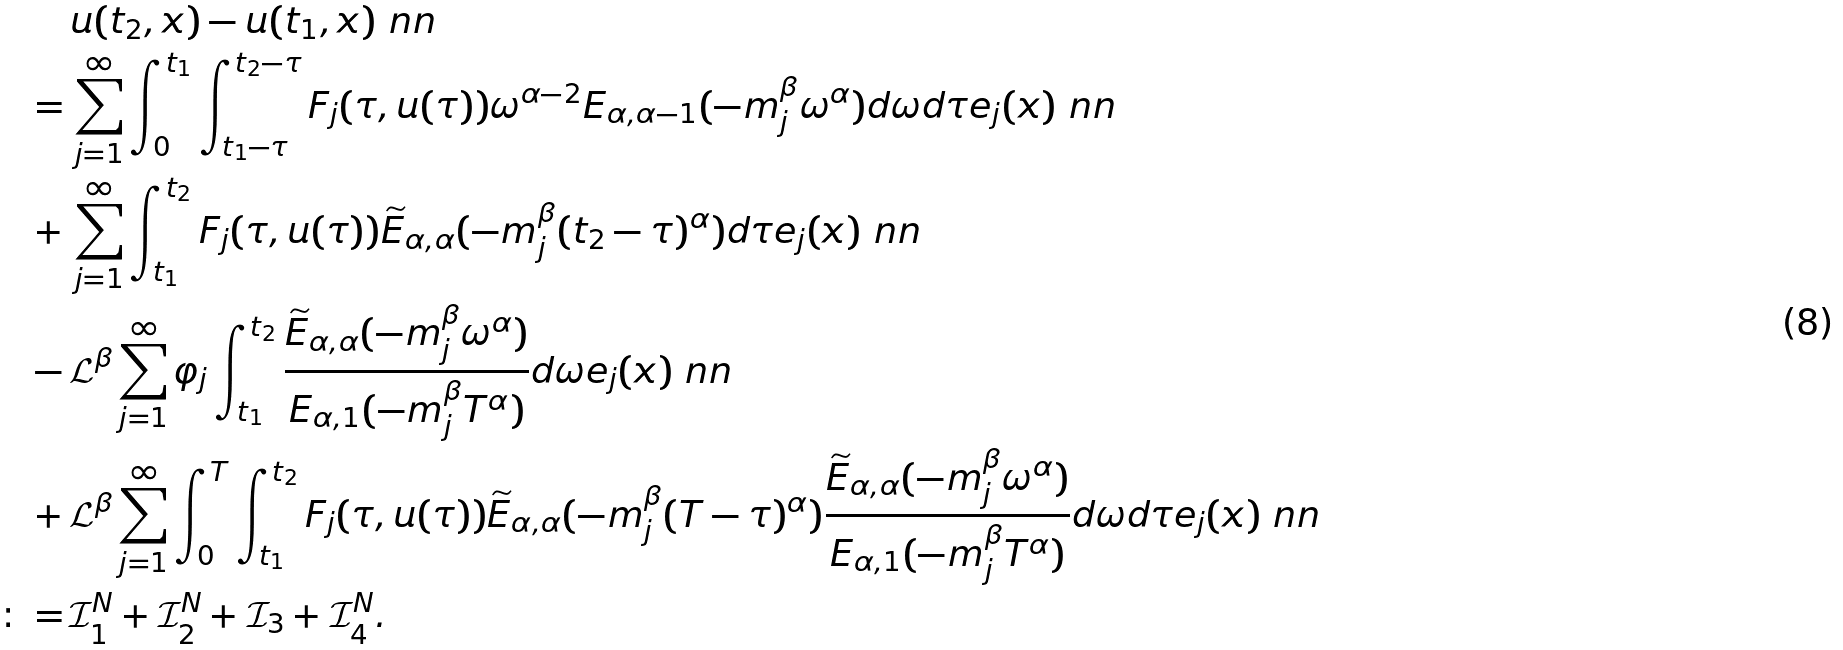Convert formula to latex. <formula><loc_0><loc_0><loc_500><loc_500>\, & u ( t _ { 2 } , x ) - u ( t _ { 1 } , x ) \ n n \\ = \, & \sum _ { j = 1 } ^ { \infty } \int _ { 0 } ^ { t _ { 1 } } \int _ { t _ { 1 } - \tau } ^ { t _ { 2 } - \tau } F _ { j } ( \tau , u ( \tau ) ) \omega ^ { \alpha - 2 } E _ { \alpha , \alpha - 1 } ( - m _ { j } ^ { \beta } \omega ^ { \alpha } ) d \omega d \tau e _ { j } ( x ) \ n n \\ + \, & \sum _ { j = 1 } ^ { \infty } \int _ { t _ { 1 } } ^ { t _ { 2 } } F _ { j } ( \tau , u ( \tau ) ) \widetilde { E } _ { \alpha , \alpha } ( - m _ { j } ^ { \beta } ( t _ { 2 } - \tau ) ^ { \alpha } ) d \tau e _ { j } ( x ) \ n n \\ - \, & \mathcal { L } ^ { \beta } \sum _ { j = 1 } ^ { \infty } \varphi _ { j } \int _ { t _ { 1 } } ^ { t _ { 2 } } \frac { \widetilde { E } _ { \alpha , \alpha } ( - m _ { j } ^ { \beta } \omega ^ { \alpha } ) } { E _ { \alpha , 1 } ( - m _ { j } ^ { \beta } T ^ { \alpha } ) } d \omega e _ { j } ( x ) \ n n \\ + \, & \mathcal { L } ^ { \beta } \sum _ { j = 1 } ^ { \infty } \int _ { 0 } ^ { T } \int _ { t _ { 1 } } ^ { t _ { 2 } } F _ { j } ( \tau , u ( \tau ) ) \widetilde { E } _ { \alpha , \alpha } ( - m _ { j } ^ { \beta } ( T - \tau ) ^ { \alpha } ) \frac { \widetilde { E } _ { \alpha , \alpha } ( - m _ { j } ^ { \beta } \omega ^ { \alpha } ) } { E _ { \alpha , 1 } ( - m _ { j } ^ { \beta } T ^ { \alpha } ) } d \omega d \tau e _ { j } ( x ) \ n n \\ \colon = \, & \mathcal { I } ^ { N } _ { 1 } + \mathcal { I } ^ { N } _ { 2 } + \mathcal { I } _ { 3 } + \mathcal { I } ^ { N } _ { 4 } .</formula> 